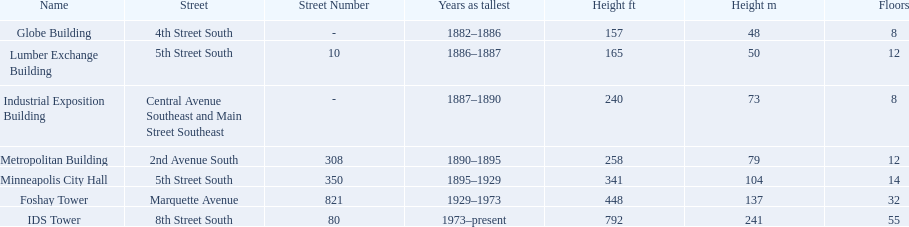What are the heights of the buildings? 157 (48), 165 (50), 240 (73), 258 (79), 341 (104), 448 (137), 792 (241). What building is 240 ft tall? Industrial Exposition Building. 